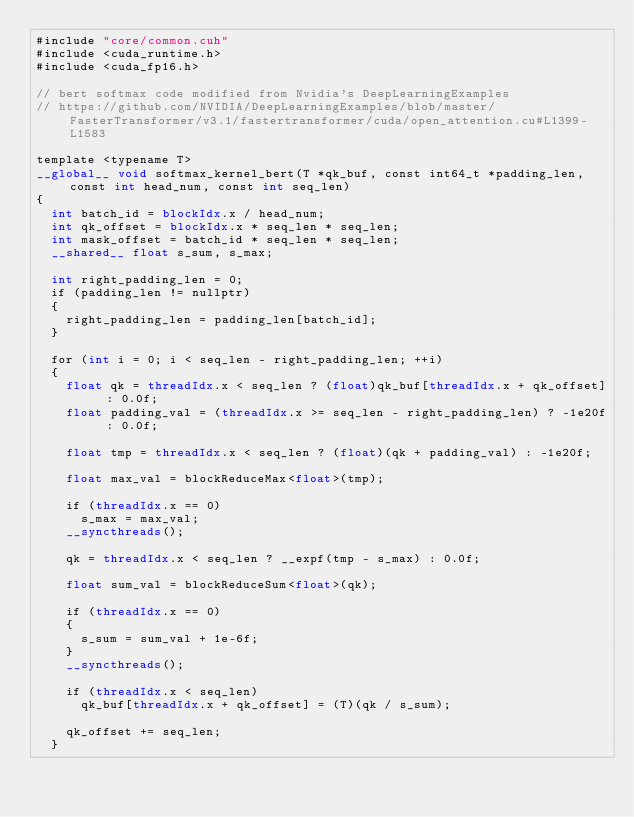Convert code to text. <code><loc_0><loc_0><loc_500><loc_500><_Cuda_>#include "core/common.cuh"
#include <cuda_runtime.h>
#include <cuda_fp16.h>

// bert softmax code modified from Nvidia's DeepLearningExamples
// https://github.com/NVIDIA/DeepLearningExamples/blob/master/FasterTransformer/v3.1/fastertransformer/cuda/open_attention.cu#L1399-L1583

template <typename T>
__global__ void softmax_kernel_bert(T *qk_buf, const int64_t *padding_len, const int head_num, const int seq_len)
{
  int batch_id = blockIdx.x / head_num;
  int qk_offset = blockIdx.x * seq_len * seq_len;
  int mask_offset = batch_id * seq_len * seq_len;
  __shared__ float s_sum, s_max;

  int right_padding_len = 0;
  if (padding_len != nullptr)
  {
    right_padding_len = padding_len[batch_id];
  }

  for (int i = 0; i < seq_len - right_padding_len; ++i)
  {
    float qk = threadIdx.x < seq_len ? (float)qk_buf[threadIdx.x + qk_offset] : 0.0f;
    float padding_val = (threadIdx.x >= seq_len - right_padding_len) ? -1e20f : 0.0f;

    float tmp = threadIdx.x < seq_len ? (float)(qk + padding_val) : -1e20f;

    float max_val = blockReduceMax<float>(tmp);

    if (threadIdx.x == 0)
      s_max = max_val;
    __syncthreads();

    qk = threadIdx.x < seq_len ? __expf(tmp - s_max) : 0.0f;

    float sum_val = blockReduceSum<float>(qk);

    if (threadIdx.x == 0)
    {
      s_sum = sum_val + 1e-6f;
    }
    __syncthreads();

    if (threadIdx.x < seq_len)
      qk_buf[threadIdx.x + qk_offset] = (T)(qk / s_sum);

    qk_offset += seq_len;
  }</code> 